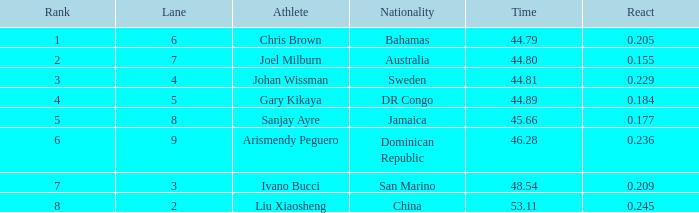How many total Rank listings have Liu Xiaosheng listed as the athlete with a react entry that is smaller than 0.245? 0.0. 